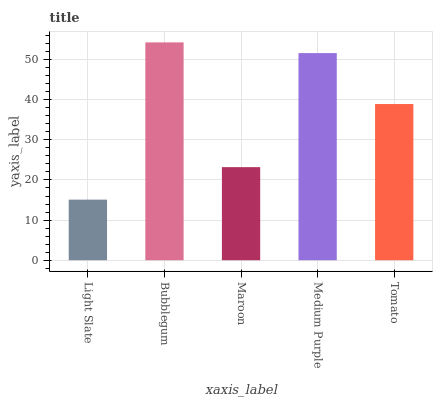Is Light Slate the minimum?
Answer yes or no. Yes. Is Bubblegum the maximum?
Answer yes or no. Yes. Is Maroon the minimum?
Answer yes or no. No. Is Maroon the maximum?
Answer yes or no. No. Is Bubblegum greater than Maroon?
Answer yes or no. Yes. Is Maroon less than Bubblegum?
Answer yes or no. Yes. Is Maroon greater than Bubblegum?
Answer yes or no. No. Is Bubblegum less than Maroon?
Answer yes or no. No. Is Tomato the high median?
Answer yes or no. Yes. Is Tomato the low median?
Answer yes or no. Yes. Is Light Slate the high median?
Answer yes or no. No. Is Medium Purple the low median?
Answer yes or no. No. 